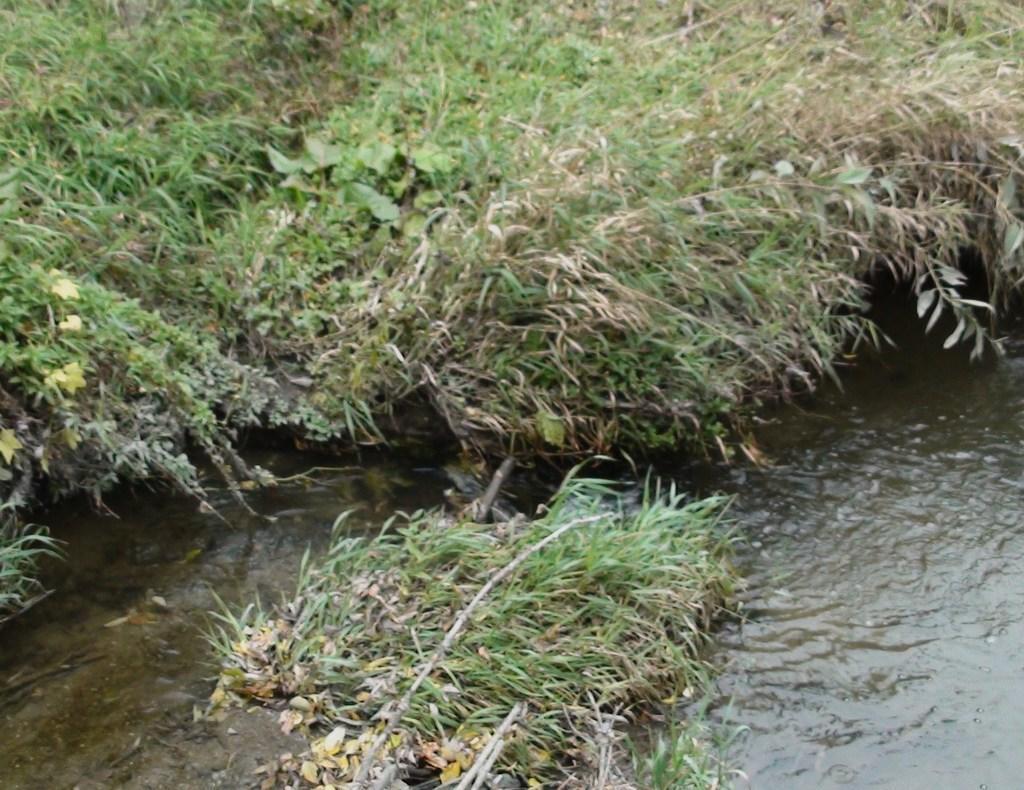How would you summarize this image in a sentence or two? In this image there is a river and a grass. 